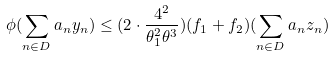<formula> <loc_0><loc_0><loc_500><loc_500>\phi ( \sum _ { n \in D } a _ { n } y _ { n } ) \leq ( 2 \cdot \frac { 4 ^ { 2 } } { \theta _ { 1 } ^ { 2 } \theta ^ { 3 } } ) ( f _ { 1 } + f _ { 2 } ) ( \sum _ { n \in D } a _ { n } z _ { n } )</formula> 